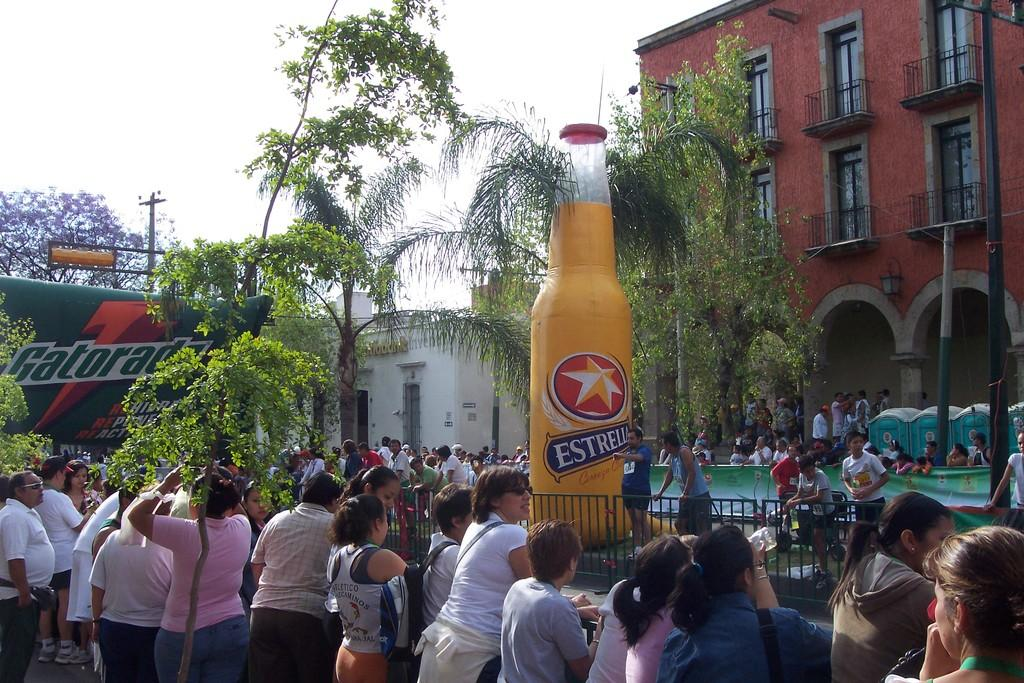<image>
Create a compact narrative representing the image presented. A gathering of people has a large inflatable bottle of Estrella in the center. 